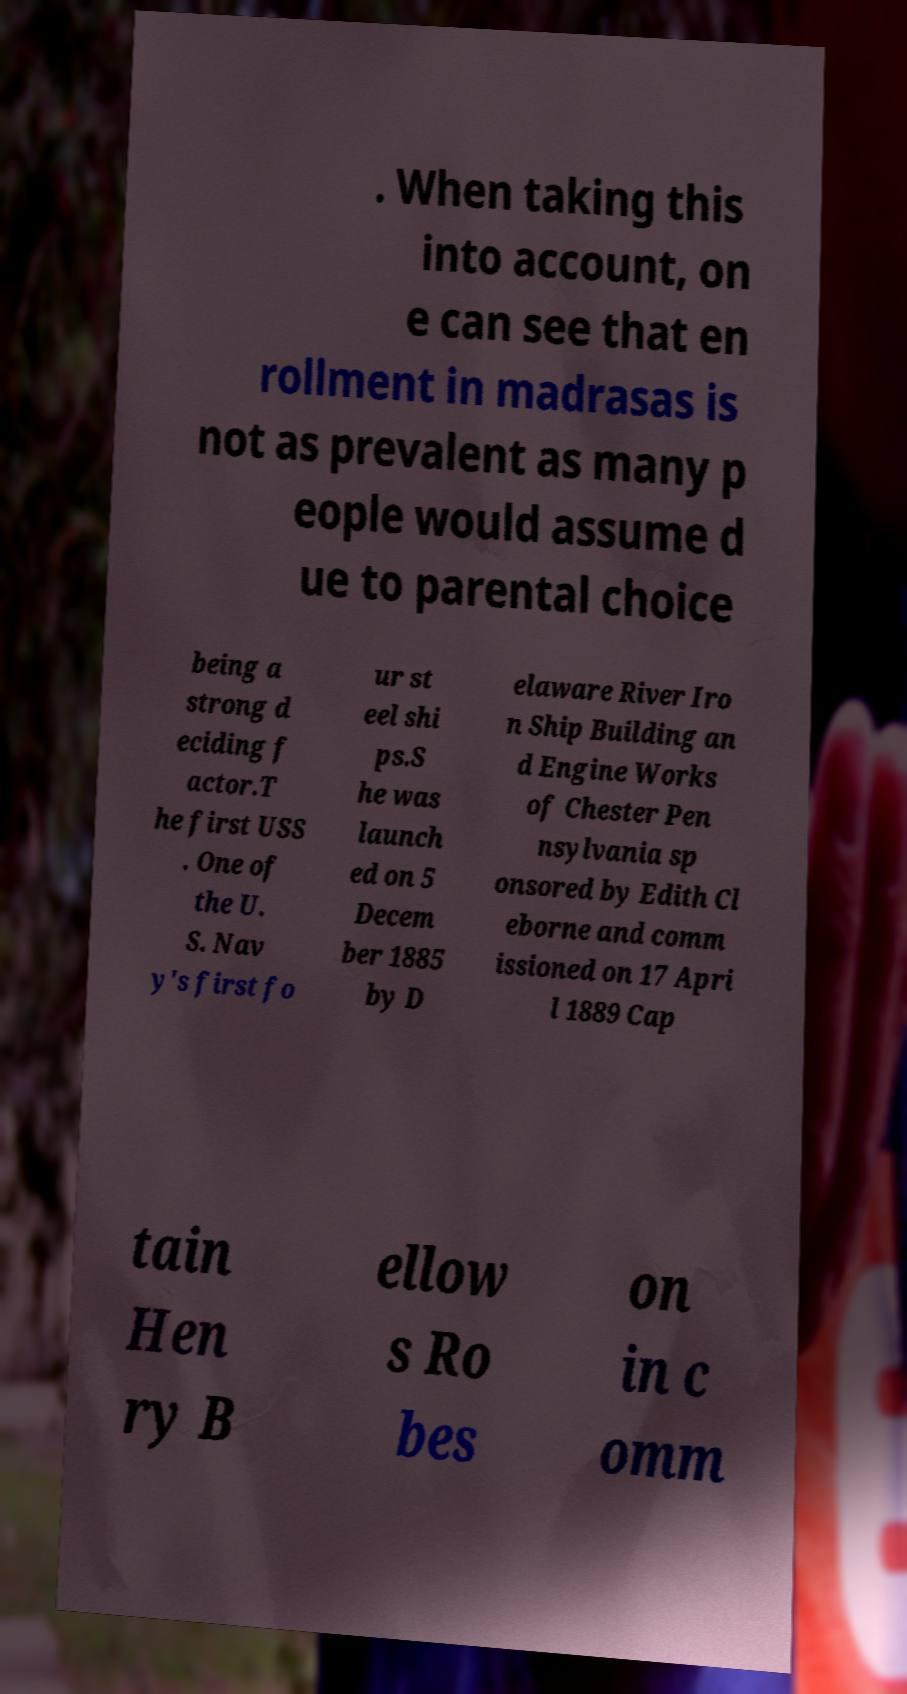For documentation purposes, I need the text within this image transcribed. Could you provide that? . When taking this into account, on e can see that en rollment in madrasas is not as prevalent as many p eople would assume d ue to parental choice being a strong d eciding f actor.T he first USS . One of the U. S. Nav y's first fo ur st eel shi ps.S he was launch ed on 5 Decem ber 1885 by D elaware River Iro n Ship Building an d Engine Works of Chester Pen nsylvania sp onsored by Edith Cl eborne and comm issioned on 17 Apri l 1889 Cap tain Hen ry B ellow s Ro bes on in c omm 